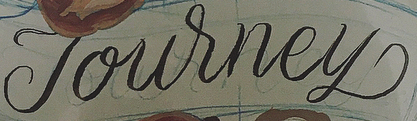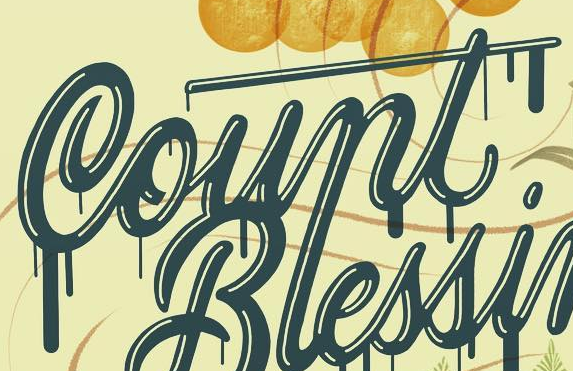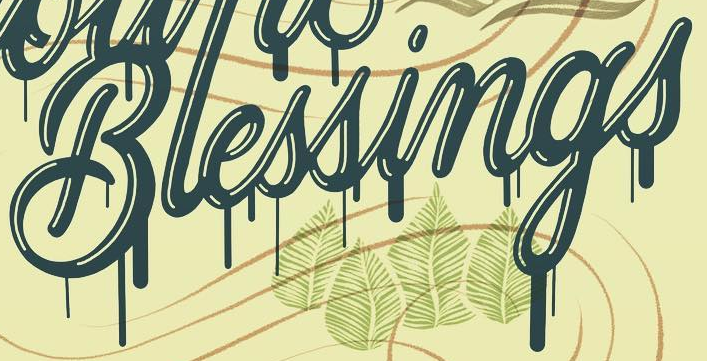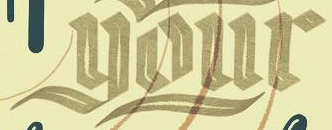Read the text from these images in sequence, separated by a semicolon. Journey; Count; Blessings; your 